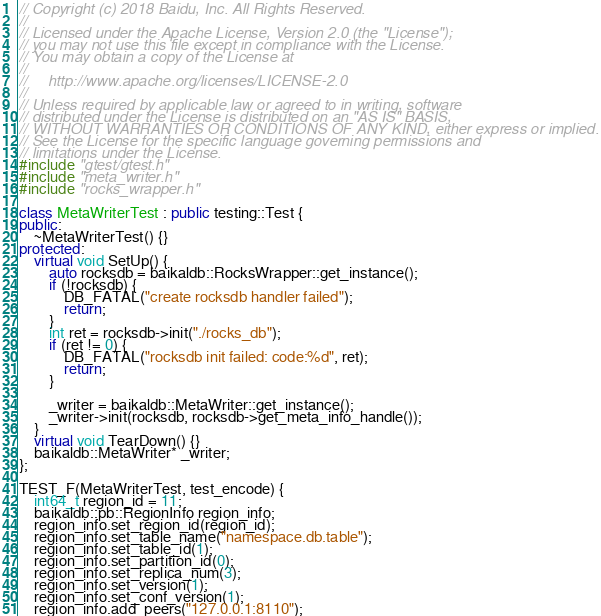<code> <loc_0><loc_0><loc_500><loc_500><_C++_>// Copyright (c) 2018 Baidu, Inc. All Rights Reserved.
//
// Licensed under the Apache License, Version 2.0 (the "License");
// you may not use this file except in compliance with the License.
// You may obtain a copy of the License at
//
//     http://www.apache.org/licenses/LICENSE-2.0
//
// Unless required by applicable law or agreed to in writing, software
// distributed under the License is distributed on an "AS IS" BASIS,
// WITHOUT WARRANTIES OR CONDITIONS OF ANY KIND, either express or implied.
// See the License for the specific language governing permissions and
// limitations under the License.
#include "gtest/gtest.h"
#include "meta_writer.h"
#include "rocks_wrapper.h"

class MetaWriterTest : public testing::Test {
public:
    ~MetaWriterTest() {}
protected:
    virtual void SetUp() {
        auto rocksdb = baikaldb::RocksWrapper::get_instance();
        if (!rocksdb) {
            DB_FATAL("create rocksdb handler failed");
            return;
        }
        int ret = rocksdb->init("./rocks_db");
        if (ret != 0) {
            DB_FATAL("rocksdb init failed: code:%d", ret);
            return;
        }
    
        _writer = baikaldb::MetaWriter::get_instance();
        _writer->init(rocksdb, rocksdb->get_meta_info_handle());
    }
    virtual void TearDown() {}
    baikaldb::MetaWriter* _writer;
};

TEST_F(MetaWriterTest, test_encode) {
    int64_t region_id = 11;
    baikaldb::pb::RegionInfo region_info;
    region_info.set_region_id(region_id);
    region_info.set_table_name("namespace.db.table");
    region_info.set_table_id(1);
    region_info.set_partition_id(0);
    region_info.set_replica_num(3);
    region_info.set_version(1);
    region_info.set_conf_version(1);
    region_info.add_peers("127.0.0.1:8110");</code> 